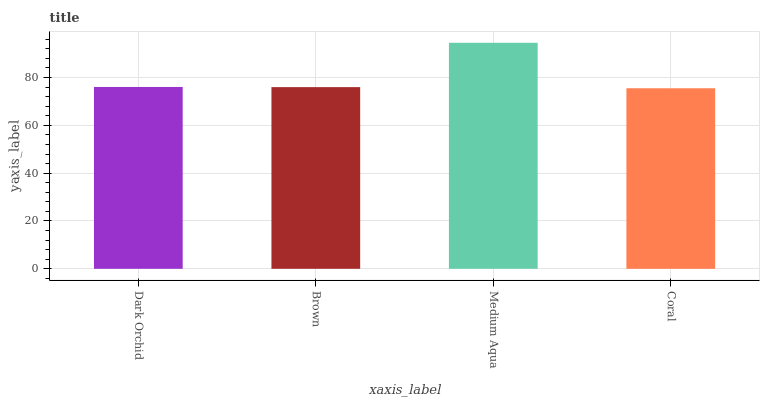Is Brown the minimum?
Answer yes or no. No. Is Brown the maximum?
Answer yes or no. No. Is Dark Orchid greater than Brown?
Answer yes or no. Yes. Is Brown less than Dark Orchid?
Answer yes or no. Yes. Is Brown greater than Dark Orchid?
Answer yes or no. No. Is Dark Orchid less than Brown?
Answer yes or no. No. Is Dark Orchid the high median?
Answer yes or no. Yes. Is Brown the low median?
Answer yes or no. Yes. Is Medium Aqua the high median?
Answer yes or no. No. Is Dark Orchid the low median?
Answer yes or no. No. 